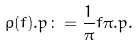<formula> <loc_0><loc_0><loc_500><loc_500>\rho ( f ) . p \colon = \frac { 1 } { \pi } f \pi . p .</formula> 